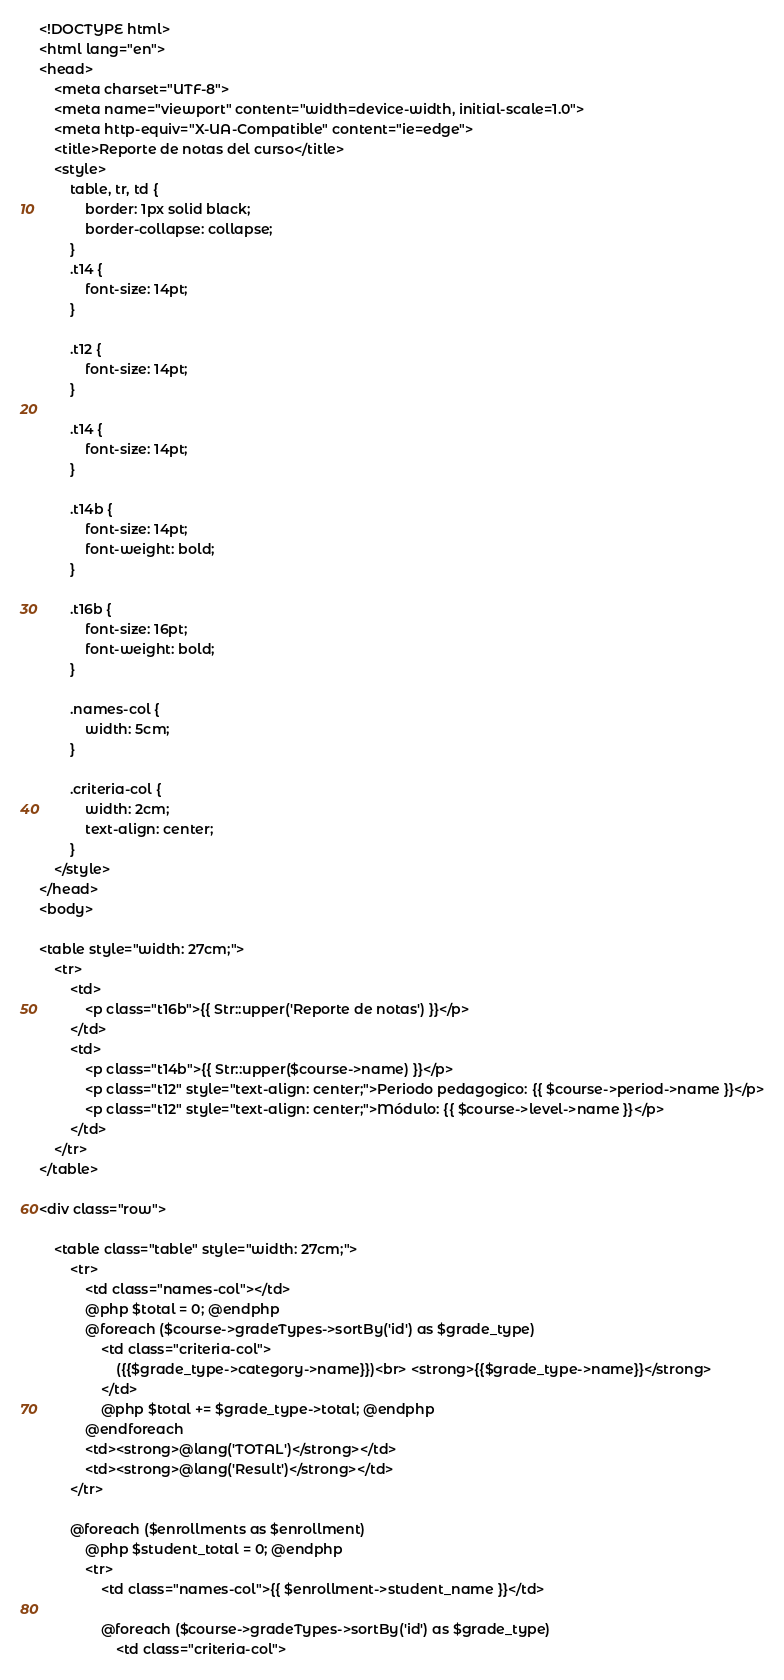Convert code to text. <code><loc_0><loc_0><loc_500><loc_500><_PHP_><!DOCTYPE html>
<html lang="en">
<head>
    <meta charset="UTF-8">
    <meta name="viewport" content="width=device-width, initial-scale=1.0">
    <meta http-equiv="X-UA-Compatible" content="ie=edge">
    <title>Reporte de notas del curso</title>
    <style>
        table, tr, td {
            border: 1px solid black;
            border-collapse: collapse;
        }
        .t14 {
            font-size: 14pt;
        }

        .t12 {
            font-size: 14pt;
        }

        .t14 {
            font-size: 14pt;
        }

        .t14b {
            font-size: 14pt;
            font-weight: bold;
        }

        .t16b {
            font-size: 16pt;
            font-weight: bold;
        }

        .names-col {
            width: 5cm;
        }

        .criteria-col {
            width: 2cm;
            text-align: center;
        }
    </style>
</head>
<body>

<table style="width: 27cm;">
    <tr>
        <td>
            <p class="t16b">{{ Str::upper('Reporte de notas') }}</p>
        </td>
        <td>
            <p class="t14b">{{ Str::upper($course->name) }}</p>
            <p class="t12" style="text-align: center;">Periodo pedagogico: {{ $course->period->name }}</p>
            <p class="t12" style="text-align: center;">Módulo: {{ $course->level->name }}</p>
        </td>
    </tr>
</table>

<div class="row">

    <table class="table" style="width: 27cm;">
        <tr>
            <td class="names-col"></td>
            @php $total = 0; @endphp
            @foreach ($course->gradeTypes->sortBy('id') as $grade_type)
                <td class="criteria-col">
                    ({{$grade_type->category->name}})<br> <strong>{{$grade_type->name}}</strong>
                </td>
                @php $total += $grade_type->total; @endphp
            @endforeach
            <td><strong>@lang('TOTAL')</strong></td>
            <td><strong>@lang('Result')</strong></td>
        </tr>

        @foreach ($enrollments as $enrollment)
            @php $student_total = 0; @endphp
            <tr>
                <td class="names-col">{{ $enrollment->student_name }}</td>

                @foreach ($course->gradeTypes->sortBy('id') as $grade_type)
                    <td class="criteria-col"></code> 